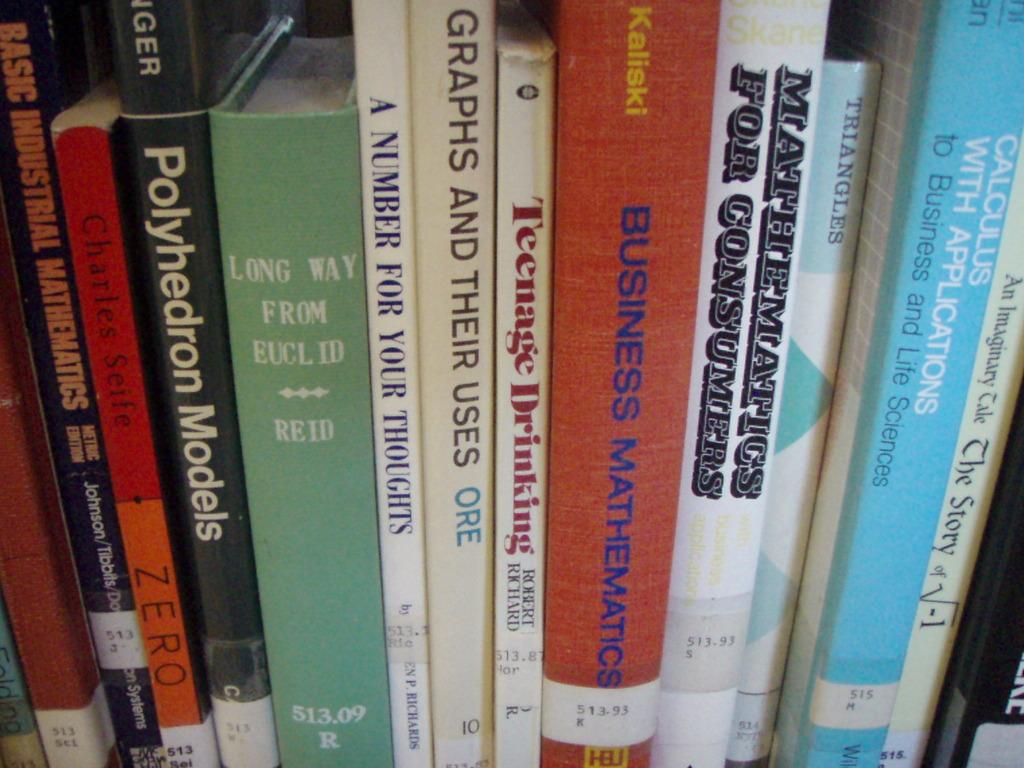What is the title of the large orange book?
Offer a very short reply. Business mathematics. Who wrote zero?
Your answer should be compact. Charles seife. 